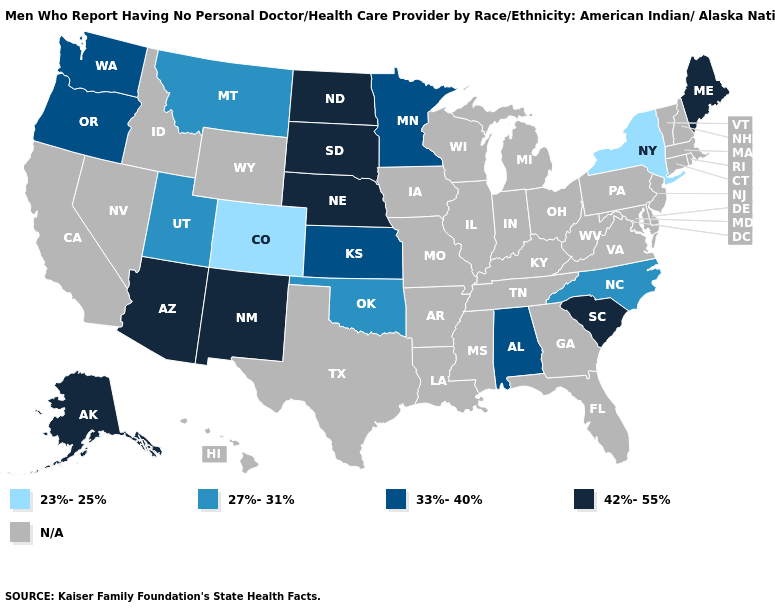What is the value of Washington?
Short answer required. 33%-40%. What is the lowest value in the Northeast?
Answer briefly. 23%-25%. Name the states that have a value in the range 42%-55%?
Give a very brief answer. Alaska, Arizona, Maine, Nebraska, New Mexico, North Dakota, South Carolina, South Dakota. What is the highest value in states that border New Jersey?
Be succinct. 23%-25%. What is the value of Maryland?
Quick response, please. N/A. What is the value of Hawaii?
Be succinct. N/A. Among the states that border Arizona , which have the highest value?
Concise answer only. New Mexico. Does Colorado have the lowest value in the West?
Give a very brief answer. Yes. What is the value of Minnesota?
Answer briefly. 33%-40%. Which states have the lowest value in the South?
Concise answer only. North Carolina, Oklahoma. Name the states that have a value in the range 33%-40%?
Answer briefly. Alabama, Kansas, Minnesota, Oregon, Washington. Which states have the highest value in the USA?
Answer briefly. Alaska, Arizona, Maine, Nebraska, New Mexico, North Dakota, South Carolina, South Dakota. What is the value of Iowa?
Quick response, please. N/A. Which states hav the highest value in the West?
Be succinct. Alaska, Arizona, New Mexico. 